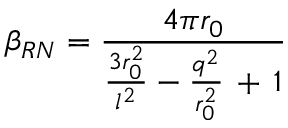Convert formula to latex. <formula><loc_0><loc_0><loc_500><loc_500>\beta _ { R N } = \frac { 4 \pi r _ { 0 } } { \frac { 3 r _ { 0 } ^ { 2 } } { l ^ { 2 } } - \frac { q ^ { 2 } } { r _ { 0 } ^ { 2 } } \, + \, 1 }</formula> 